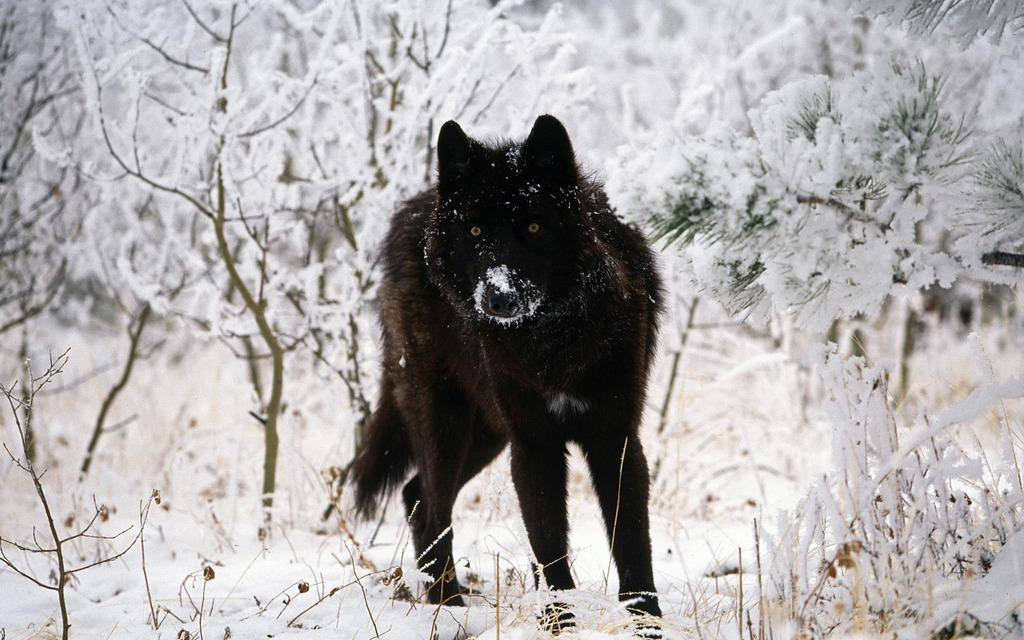What type of animal can be seen in the image? There is an animal in the image, but we cannot determine its specific type from the provided facts. What is the weather like in the image? There is snow in the image, which suggests a cold and wintry environment. What type of vegetation is present in the image? There are plants and trees in the image. What type of copper drink is the animal holding in the image? There is no mention of a copper drink or any drink in the image. The animal is not holding anything, and there is no reference to a drink or copper in the provided facts. 